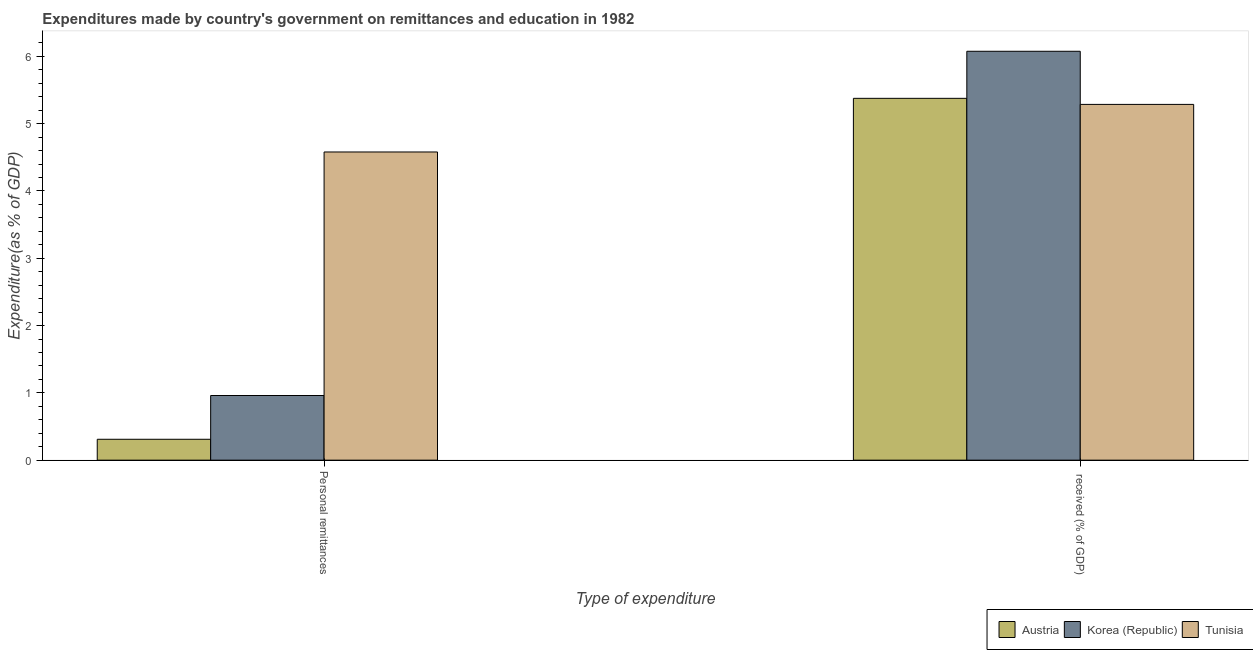Are the number of bars per tick equal to the number of legend labels?
Make the answer very short. Yes. How many bars are there on the 1st tick from the right?
Provide a succinct answer. 3. What is the label of the 2nd group of bars from the left?
Offer a very short reply.  received (% of GDP). What is the expenditure in personal remittances in Korea (Republic)?
Offer a very short reply. 0.96. Across all countries, what is the maximum expenditure in education?
Offer a very short reply. 6.08. Across all countries, what is the minimum expenditure in personal remittances?
Keep it short and to the point. 0.31. In which country was the expenditure in education maximum?
Your answer should be compact. Korea (Republic). What is the total expenditure in education in the graph?
Provide a short and direct response. 16.74. What is the difference between the expenditure in education in Korea (Republic) and that in Tunisia?
Your answer should be very brief. 0.79. What is the difference between the expenditure in education in Austria and the expenditure in personal remittances in Korea (Republic)?
Ensure brevity in your answer.  4.42. What is the average expenditure in education per country?
Your response must be concise. 5.58. What is the difference between the expenditure in education and expenditure in personal remittances in Korea (Republic)?
Give a very brief answer. 5.11. What is the ratio of the expenditure in education in Austria to that in Tunisia?
Make the answer very short. 1.02. In how many countries, is the expenditure in education greater than the average expenditure in education taken over all countries?
Provide a short and direct response. 1. What does the 2nd bar from the left in  received (% of GDP) represents?
Provide a succinct answer. Korea (Republic). What does the 1st bar from the right in Personal remittances represents?
Provide a short and direct response. Tunisia. How many bars are there?
Your answer should be very brief. 6. Are all the bars in the graph horizontal?
Your answer should be compact. No. How many countries are there in the graph?
Your response must be concise. 3. What is the difference between two consecutive major ticks on the Y-axis?
Offer a very short reply. 1. Are the values on the major ticks of Y-axis written in scientific E-notation?
Offer a very short reply. No. Does the graph contain grids?
Offer a very short reply. No. How many legend labels are there?
Offer a terse response. 3. How are the legend labels stacked?
Keep it short and to the point. Horizontal. What is the title of the graph?
Provide a succinct answer. Expenditures made by country's government on remittances and education in 1982. What is the label or title of the X-axis?
Provide a succinct answer. Type of expenditure. What is the label or title of the Y-axis?
Make the answer very short. Expenditure(as % of GDP). What is the Expenditure(as % of GDP) in Austria in Personal remittances?
Keep it short and to the point. 0.31. What is the Expenditure(as % of GDP) in Korea (Republic) in Personal remittances?
Give a very brief answer. 0.96. What is the Expenditure(as % of GDP) in Tunisia in Personal remittances?
Your answer should be very brief. 4.58. What is the Expenditure(as % of GDP) in Austria in  received (% of GDP)?
Keep it short and to the point. 5.38. What is the Expenditure(as % of GDP) of Korea (Republic) in  received (% of GDP)?
Offer a very short reply. 6.08. What is the Expenditure(as % of GDP) in Tunisia in  received (% of GDP)?
Give a very brief answer. 5.29. Across all Type of expenditure, what is the maximum Expenditure(as % of GDP) of Austria?
Provide a short and direct response. 5.38. Across all Type of expenditure, what is the maximum Expenditure(as % of GDP) in Korea (Republic)?
Keep it short and to the point. 6.08. Across all Type of expenditure, what is the maximum Expenditure(as % of GDP) in Tunisia?
Make the answer very short. 5.29. Across all Type of expenditure, what is the minimum Expenditure(as % of GDP) in Austria?
Your answer should be very brief. 0.31. Across all Type of expenditure, what is the minimum Expenditure(as % of GDP) in Korea (Republic)?
Your answer should be very brief. 0.96. Across all Type of expenditure, what is the minimum Expenditure(as % of GDP) in Tunisia?
Your answer should be very brief. 4.58. What is the total Expenditure(as % of GDP) in Austria in the graph?
Your answer should be very brief. 5.69. What is the total Expenditure(as % of GDP) of Korea (Republic) in the graph?
Ensure brevity in your answer.  7.04. What is the total Expenditure(as % of GDP) in Tunisia in the graph?
Ensure brevity in your answer.  9.87. What is the difference between the Expenditure(as % of GDP) of Austria in Personal remittances and that in  received (% of GDP)?
Provide a short and direct response. -5.07. What is the difference between the Expenditure(as % of GDP) of Korea (Republic) in Personal remittances and that in  received (% of GDP)?
Provide a succinct answer. -5.11. What is the difference between the Expenditure(as % of GDP) of Tunisia in Personal remittances and that in  received (% of GDP)?
Provide a succinct answer. -0.71. What is the difference between the Expenditure(as % of GDP) of Austria in Personal remittances and the Expenditure(as % of GDP) of Korea (Republic) in  received (% of GDP)?
Your answer should be compact. -5.76. What is the difference between the Expenditure(as % of GDP) in Austria in Personal remittances and the Expenditure(as % of GDP) in Tunisia in  received (% of GDP)?
Give a very brief answer. -4.98. What is the difference between the Expenditure(as % of GDP) in Korea (Republic) in Personal remittances and the Expenditure(as % of GDP) in Tunisia in  received (% of GDP)?
Make the answer very short. -4.33. What is the average Expenditure(as % of GDP) of Austria per Type of expenditure?
Offer a very short reply. 2.84. What is the average Expenditure(as % of GDP) in Korea (Republic) per Type of expenditure?
Provide a short and direct response. 3.52. What is the average Expenditure(as % of GDP) of Tunisia per Type of expenditure?
Offer a terse response. 4.93. What is the difference between the Expenditure(as % of GDP) in Austria and Expenditure(as % of GDP) in Korea (Republic) in Personal remittances?
Your response must be concise. -0.65. What is the difference between the Expenditure(as % of GDP) in Austria and Expenditure(as % of GDP) in Tunisia in Personal remittances?
Give a very brief answer. -4.27. What is the difference between the Expenditure(as % of GDP) of Korea (Republic) and Expenditure(as % of GDP) of Tunisia in Personal remittances?
Make the answer very short. -3.62. What is the difference between the Expenditure(as % of GDP) of Austria and Expenditure(as % of GDP) of Korea (Republic) in  received (% of GDP)?
Make the answer very short. -0.7. What is the difference between the Expenditure(as % of GDP) of Austria and Expenditure(as % of GDP) of Tunisia in  received (% of GDP)?
Your answer should be compact. 0.09. What is the difference between the Expenditure(as % of GDP) in Korea (Republic) and Expenditure(as % of GDP) in Tunisia in  received (% of GDP)?
Your answer should be very brief. 0.79. What is the ratio of the Expenditure(as % of GDP) of Austria in Personal remittances to that in  received (% of GDP)?
Ensure brevity in your answer.  0.06. What is the ratio of the Expenditure(as % of GDP) of Korea (Republic) in Personal remittances to that in  received (% of GDP)?
Provide a succinct answer. 0.16. What is the ratio of the Expenditure(as % of GDP) in Tunisia in Personal remittances to that in  received (% of GDP)?
Your response must be concise. 0.87. What is the difference between the highest and the second highest Expenditure(as % of GDP) of Austria?
Offer a very short reply. 5.07. What is the difference between the highest and the second highest Expenditure(as % of GDP) of Korea (Republic)?
Keep it short and to the point. 5.11. What is the difference between the highest and the second highest Expenditure(as % of GDP) of Tunisia?
Your response must be concise. 0.71. What is the difference between the highest and the lowest Expenditure(as % of GDP) of Austria?
Offer a terse response. 5.07. What is the difference between the highest and the lowest Expenditure(as % of GDP) in Korea (Republic)?
Provide a short and direct response. 5.11. What is the difference between the highest and the lowest Expenditure(as % of GDP) of Tunisia?
Your response must be concise. 0.71. 